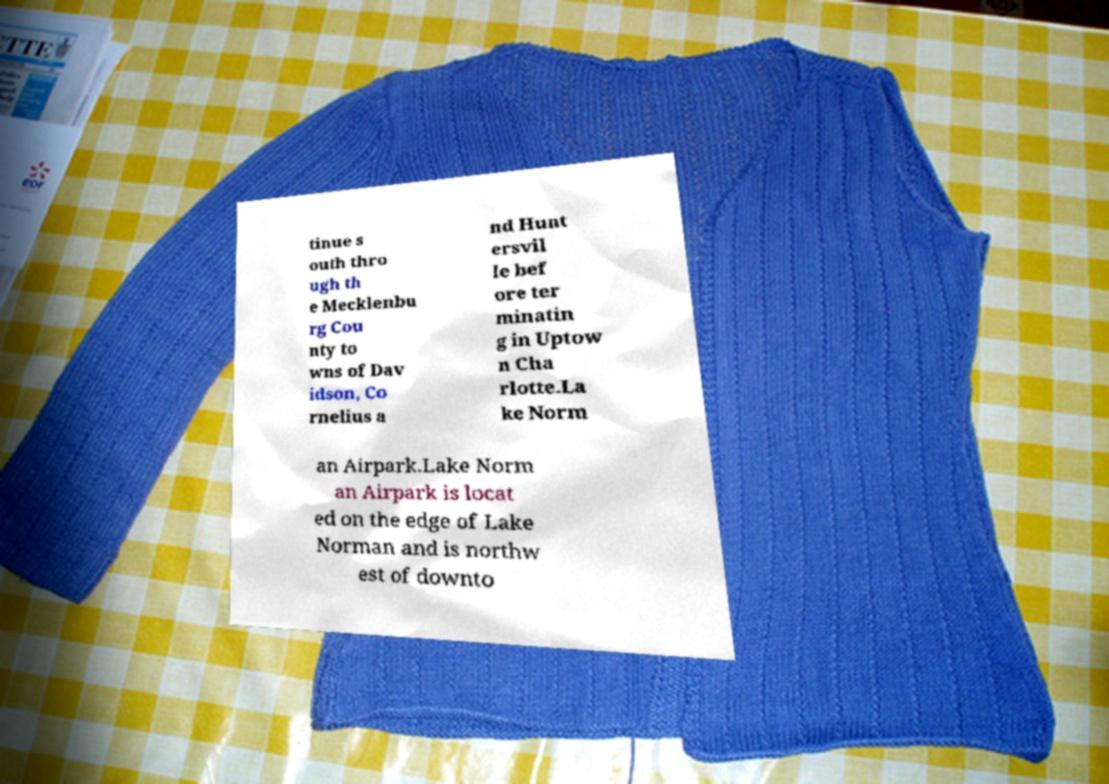Could you assist in decoding the text presented in this image and type it out clearly? tinue s outh thro ugh th e Mecklenbu rg Cou nty to wns of Dav idson, Co rnelius a nd Hunt ersvil le bef ore ter minatin g in Uptow n Cha rlotte.La ke Norm an Airpark.Lake Norm an Airpark is locat ed on the edge of Lake Norman and is northw est of downto 